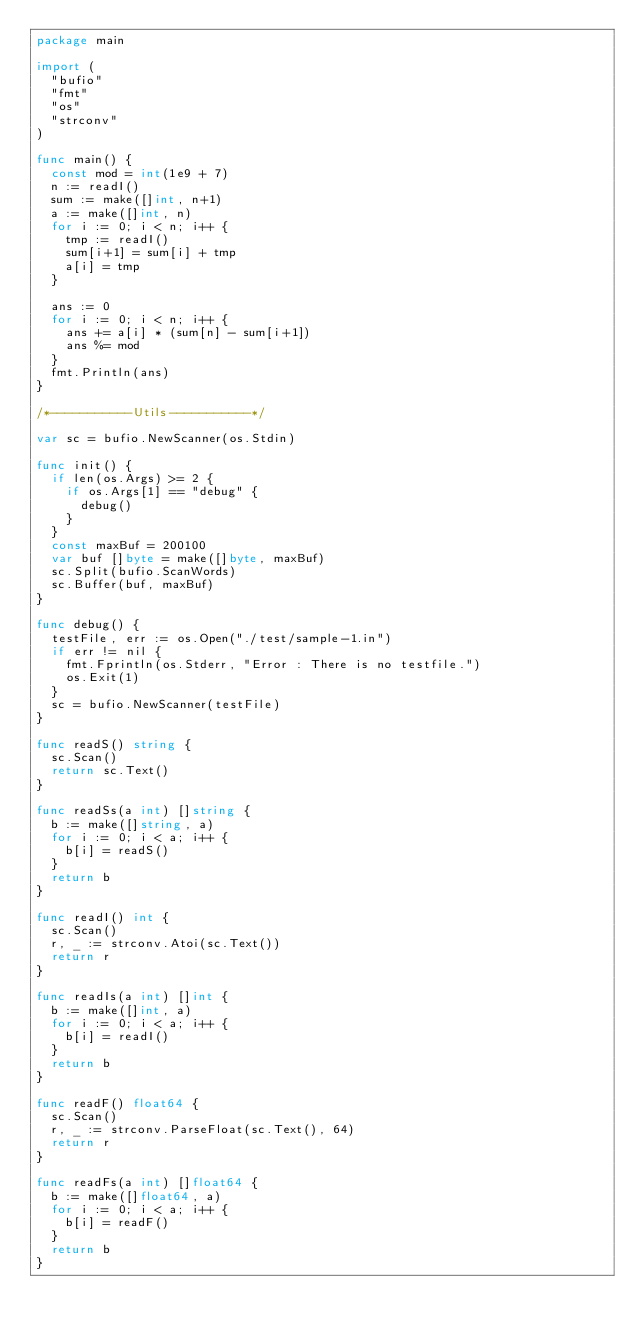<code> <loc_0><loc_0><loc_500><loc_500><_Go_>package main

import (
	"bufio"
	"fmt"
	"os"
	"strconv"
)

func main() {
	const mod = int(1e9 + 7)
	n := readI()
	sum := make([]int, n+1)
	a := make([]int, n)
	for i := 0; i < n; i++ {
		tmp := readI()
		sum[i+1] = sum[i] + tmp
		a[i] = tmp
	}

	ans := 0
	for i := 0; i < n; i++ {
		ans += a[i] * (sum[n] - sum[i+1])
		ans %= mod
	}
	fmt.Println(ans)
}

/*-----------Utils-----------*/

var sc = bufio.NewScanner(os.Stdin)

func init() {
	if len(os.Args) >= 2 {
		if os.Args[1] == "debug" {
			debug()
		}
	}
	const maxBuf = 200100
	var buf []byte = make([]byte, maxBuf)
	sc.Split(bufio.ScanWords)
	sc.Buffer(buf, maxBuf)
}

func debug() {
	testFile, err := os.Open("./test/sample-1.in")
	if err != nil {
		fmt.Fprintln(os.Stderr, "Error : There is no testfile.")
		os.Exit(1)
	}
	sc = bufio.NewScanner(testFile)
}

func readS() string {
	sc.Scan()
	return sc.Text()
}

func readSs(a int) []string {
	b := make([]string, a)
	for i := 0; i < a; i++ {
		b[i] = readS()
	}
	return b
}

func readI() int {
	sc.Scan()
	r, _ := strconv.Atoi(sc.Text())
	return r
}

func readIs(a int) []int {
	b := make([]int, a)
	for i := 0; i < a; i++ {
		b[i] = readI()
	}
	return b
}

func readF() float64 {
	sc.Scan()
	r, _ := strconv.ParseFloat(sc.Text(), 64)
	return r
}

func readFs(a int) []float64 {
	b := make([]float64, a)
	for i := 0; i < a; i++ {
		b[i] = readF()
	}
	return b
}
</code> 